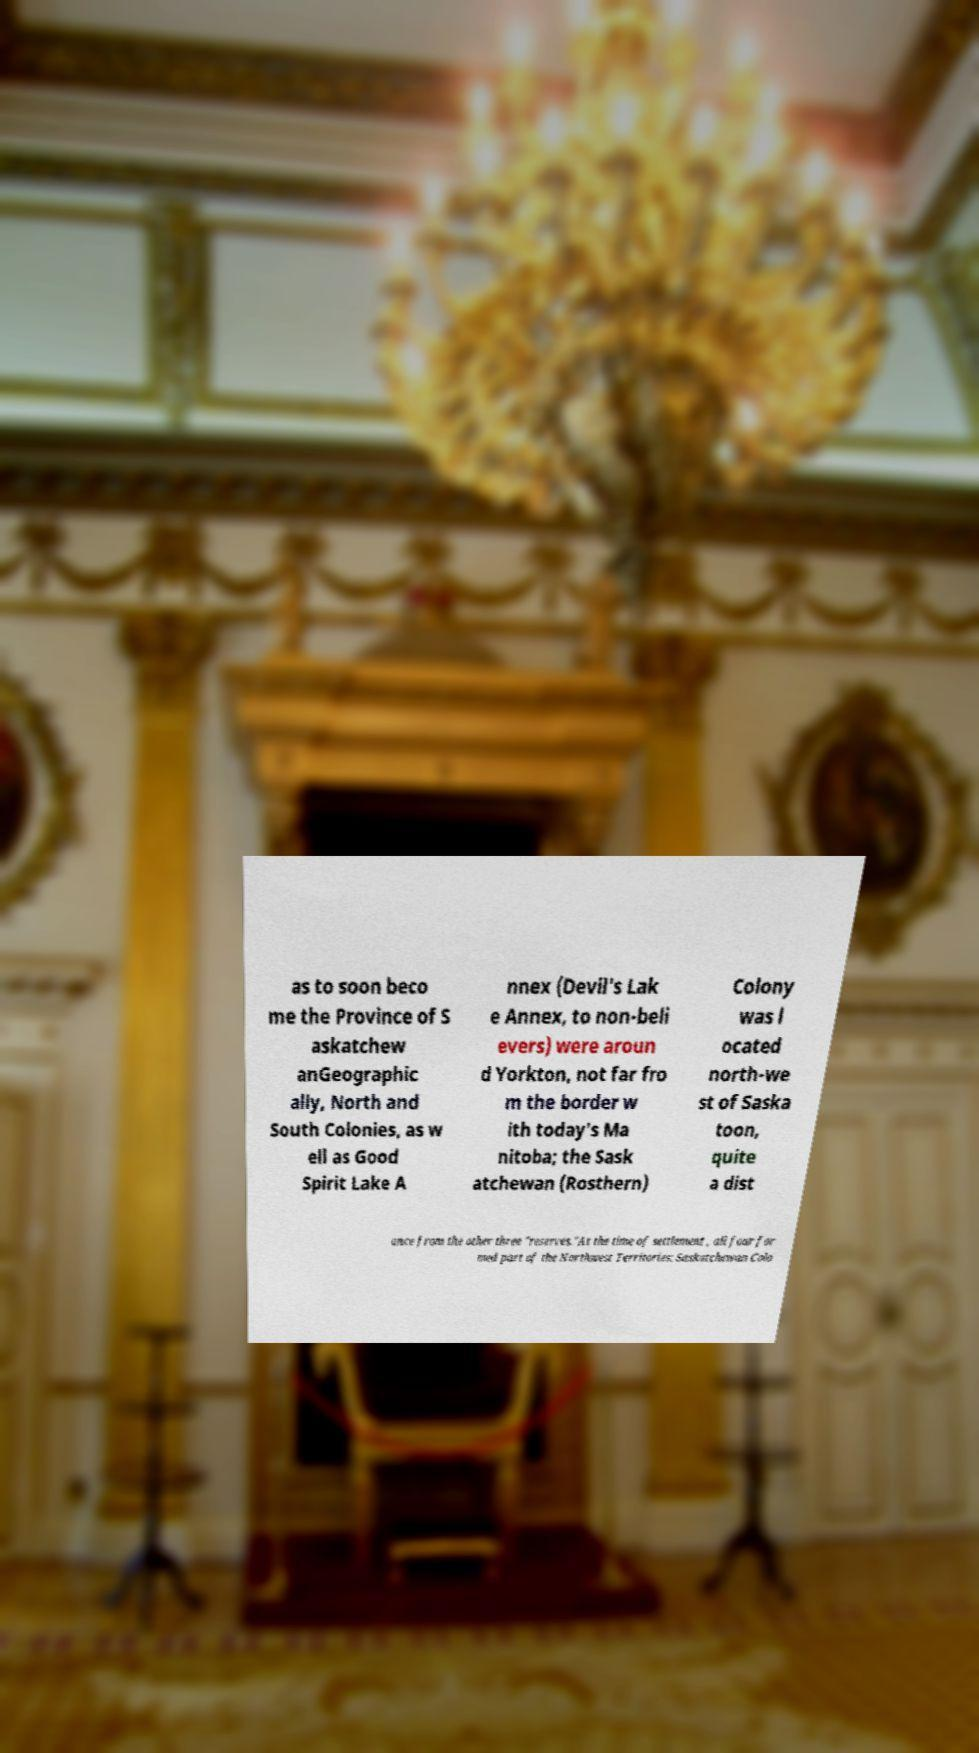For documentation purposes, I need the text within this image transcribed. Could you provide that? as to soon beco me the Province of S askatchew anGeographic ally, North and South Colonies, as w ell as Good Spirit Lake A nnex (Devil's Lak e Annex, to non-beli evers) were aroun d Yorkton, not far fro m the border w ith today's Ma nitoba; the Sask atchewan (Rosthern) Colony was l ocated north-we st of Saska toon, quite a dist ance from the other three "reserves."At the time of settlement , all four for med part of the Northwest Territories: Saskatchewan Colo 